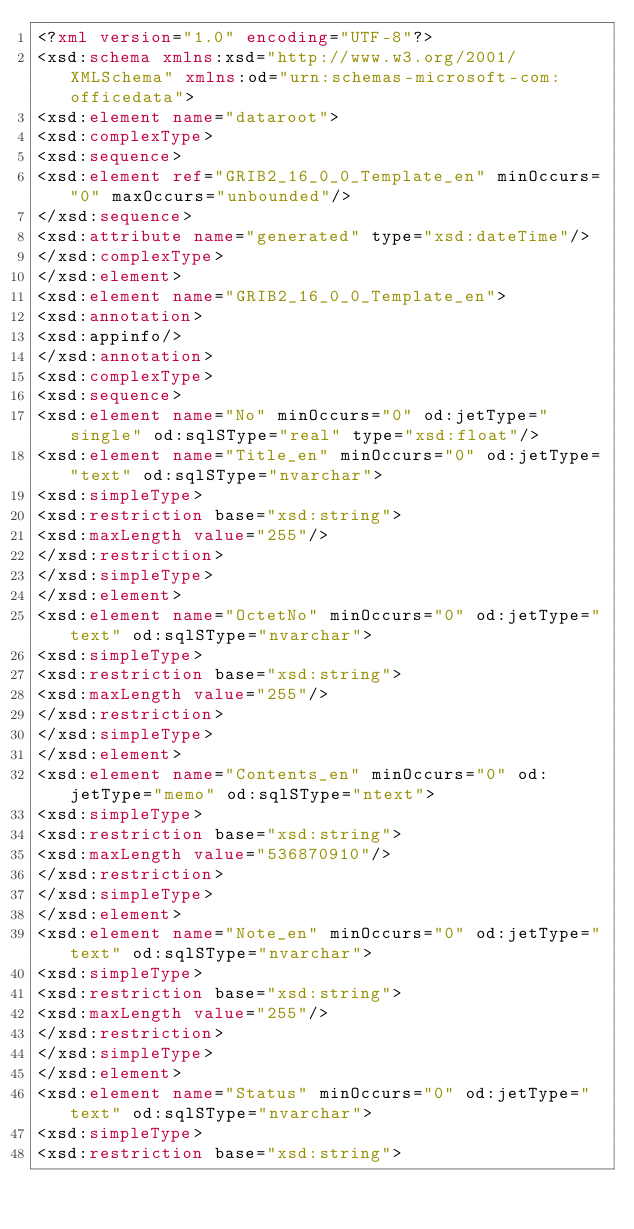<code> <loc_0><loc_0><loc_500><loc_500><_XML_><?xml version="1.0" encoding="UTF-8"?>
<xsd:schema xmlns:xsd="http://www.w3.org/2001/XMLSchema" xmlns:od="urn:schemas-microsoft-com:officedata">
<xsd:element name="dataroot">
<xsd:complexType>
<xsd:sequence>
<xsd:element ref="GRIB2_16_0_0_Template_en" minOccurs="0" maxOccurs="unbounded"/>
</xsd:sequence>
<xsd:attribute name="generated" type="xsd:dateTime"/>
</xsd:complexType>
</xsd:element>
<xsd:element name="GRIB2_16_0_0_Template_en">
<xsd:annotation>
<xsd:appinfo/>
</xsd:annotation>
<xsd:complexType>
<xsd:sequence>
<xsd:element name="No" minOccurs="0" od:jetType="single" od:sqlSType="real" type="xsd:float"/>
<xsd:element name="Title_en" minOccurs="0" od:jetType="text" od:sqlSType="nvarchar">
<xsd:simpleType>
<xsd:restriction base="xsd:string">
<xsd:maxLength value="255"/>
</xsd:restriction>
</xsd:simpleType>
</xsd:element>
<xsd:element name="OctetNo" minOccurs="0" od:jetType="text" od:sqlSType="nvarchar">
<xsd:simpleType>
<xsd:restriction base="xsd:string">
<xsd:maxLength value="255"/>
</xsd:restriction>
</xsd:simpleType>
</xsd:element>
<xsd:element name="Contents_en" minOccurs="0" od:jetType="memo" od:sqlSType="ntext">
<xsd:simpleType>
<xsd:restriction base="xsd:string">
<xsd:maxLength value="536870910"/>
</xsd:restriction>
</xsd:simpleType>
</xsd:element>
<xsd:element name="Note_en" minOccurs="0" od:jetType="text" od:sqlSType="nvarchar">
<xsd:simpleType>
<xsd:restriction base="xsd:string">
<xsd:maxLength value="255"/>
</xsd:restriction>
</xsd:simpleType>
</xsd:element>
<xsd:element name="Status" minOccurs="0" od:jetType="text" od:sqlSType="nvarchar">
<xsd:simpleType>
<xsd:restriction base="xsd:string"></code> 